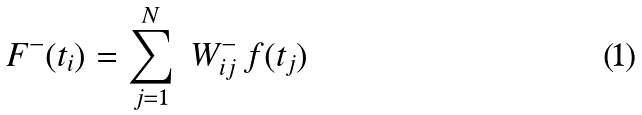Convert formula to latex. <formula><loc_0><loc_0><loc_500><loc_500>F ^ { - } ( t _ { i } ) = \sum _ { j = 1 } ^ { N } \ W ^ { - } _ { i j } \, f ( t _ { j } )</formula> 